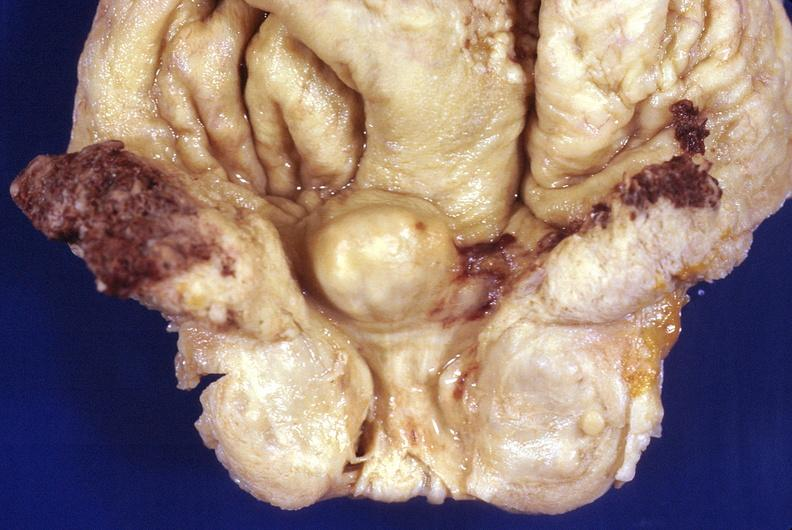does hydrocele show prostatic hyperplasia?
Answer the question using a single word or phrase. No 